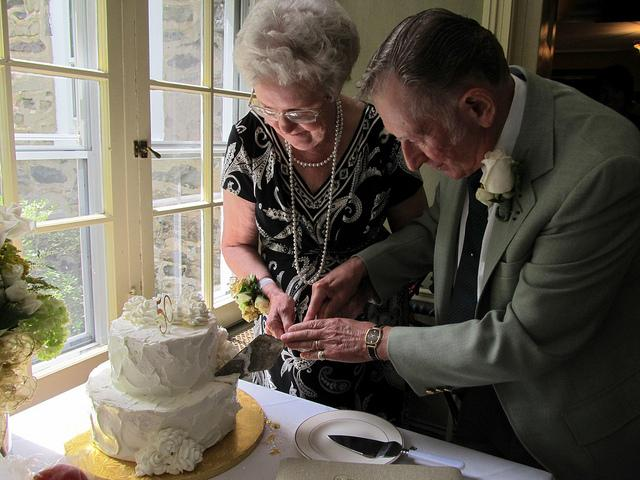Which occasion is this for? anniversary 